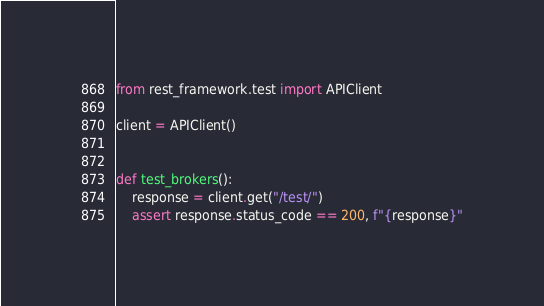<code> <loc_0><loc_0><loc_500><loc_500><_Python_>from rest_framework.test import APIClient

client = APIClient()


def test_brokers():
    response = client.get("/test/")
    assert response.status_code == 200, f"{response}"
</code> 